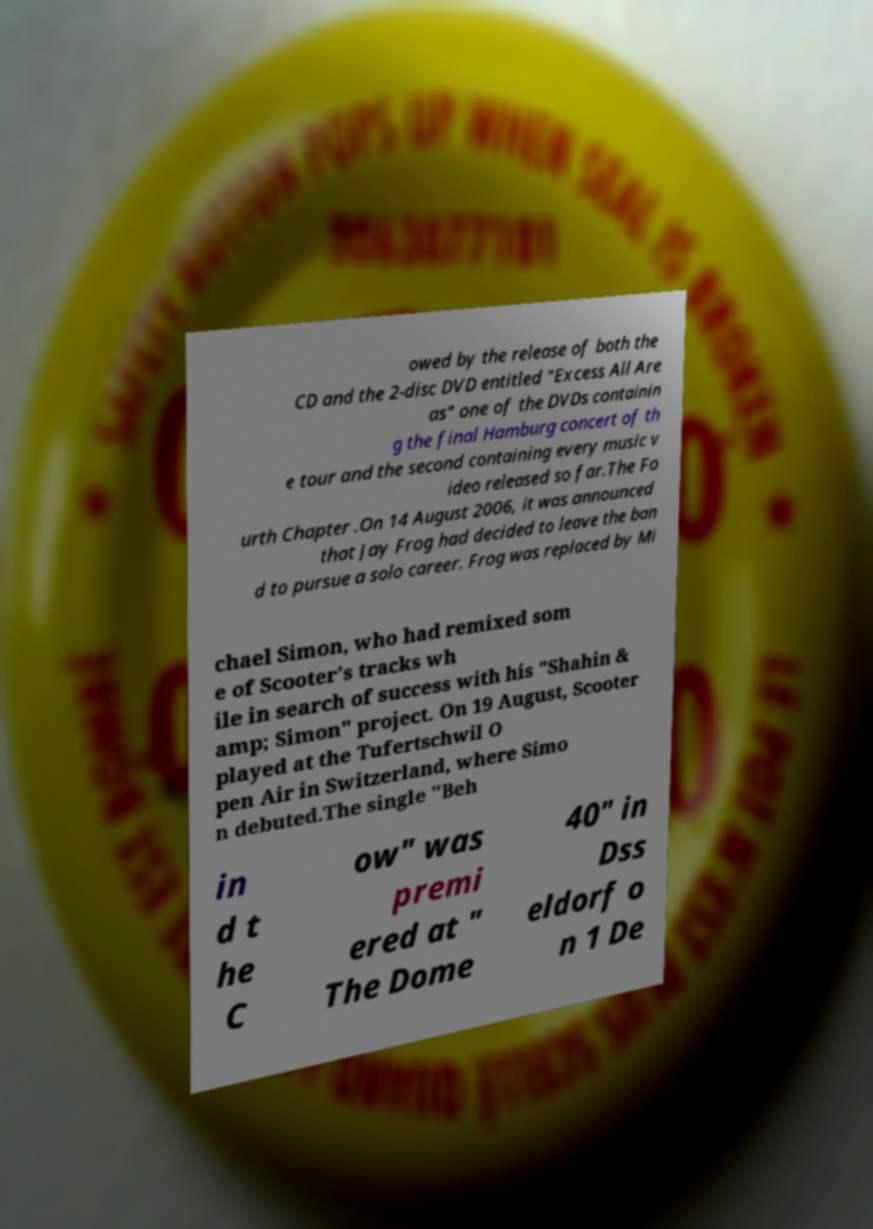Please identify and transcribe the text found in this image. owed by the release of both the CD and the 2-disc DVD entitled "Excess All Are as" one of the DVDs containin g the final Hamburg concert of th e tour and the second containing every music v ideo released so far.The Fo urth Chapter .On 14 August 2006, it was announced that Jay Frog had decided to leave the ban d to pursue a solo career. Frog was replaced by Mi chael Simon, who had remixed som e of Scooter's tracks wh ile in search of success with his "Shahin & amp; Simon" project. On 19 August, Scooter played at the Tufertschwil O pen Air in Switzerland, where Simo n debuted.The single "Beh in d t he C ow" was premi ered at " The Dome 40" in Dss eldorf o n 1 De 